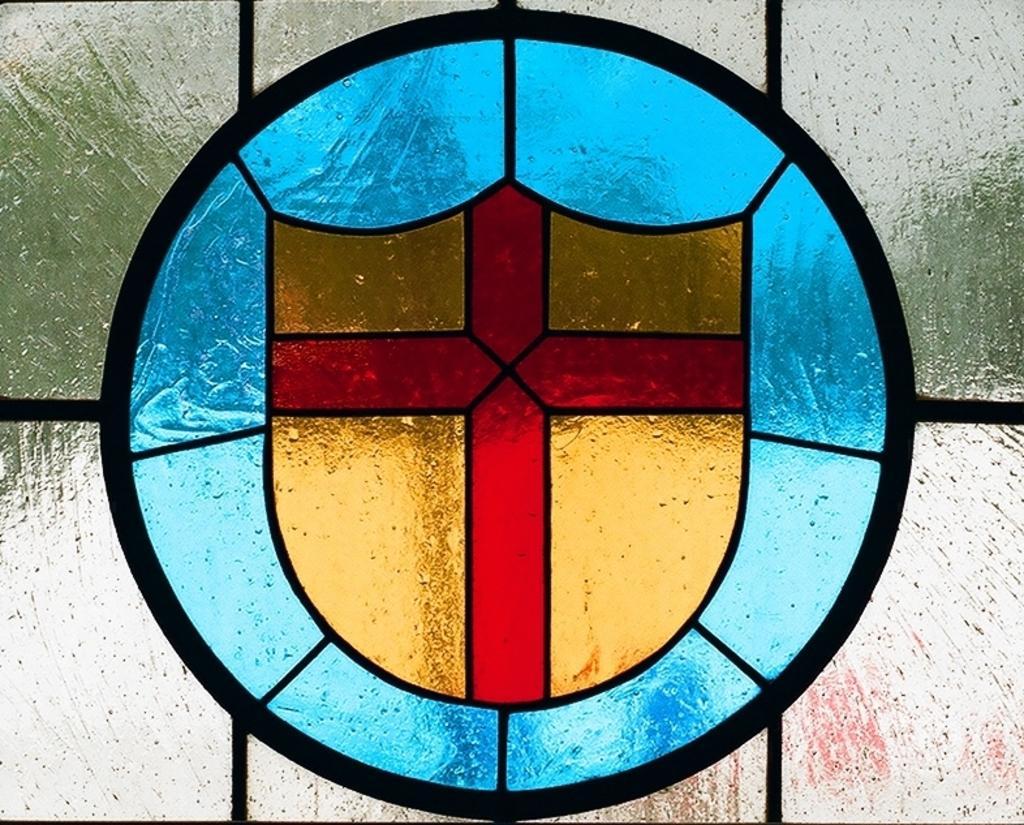Can you describe this image briefly? In the middle of this image, there is a painting on a glass. This painting is having a red color cross on a golden color shield. Around this shield, there is a blue color painting. Around this painting, there is a black color circle. 